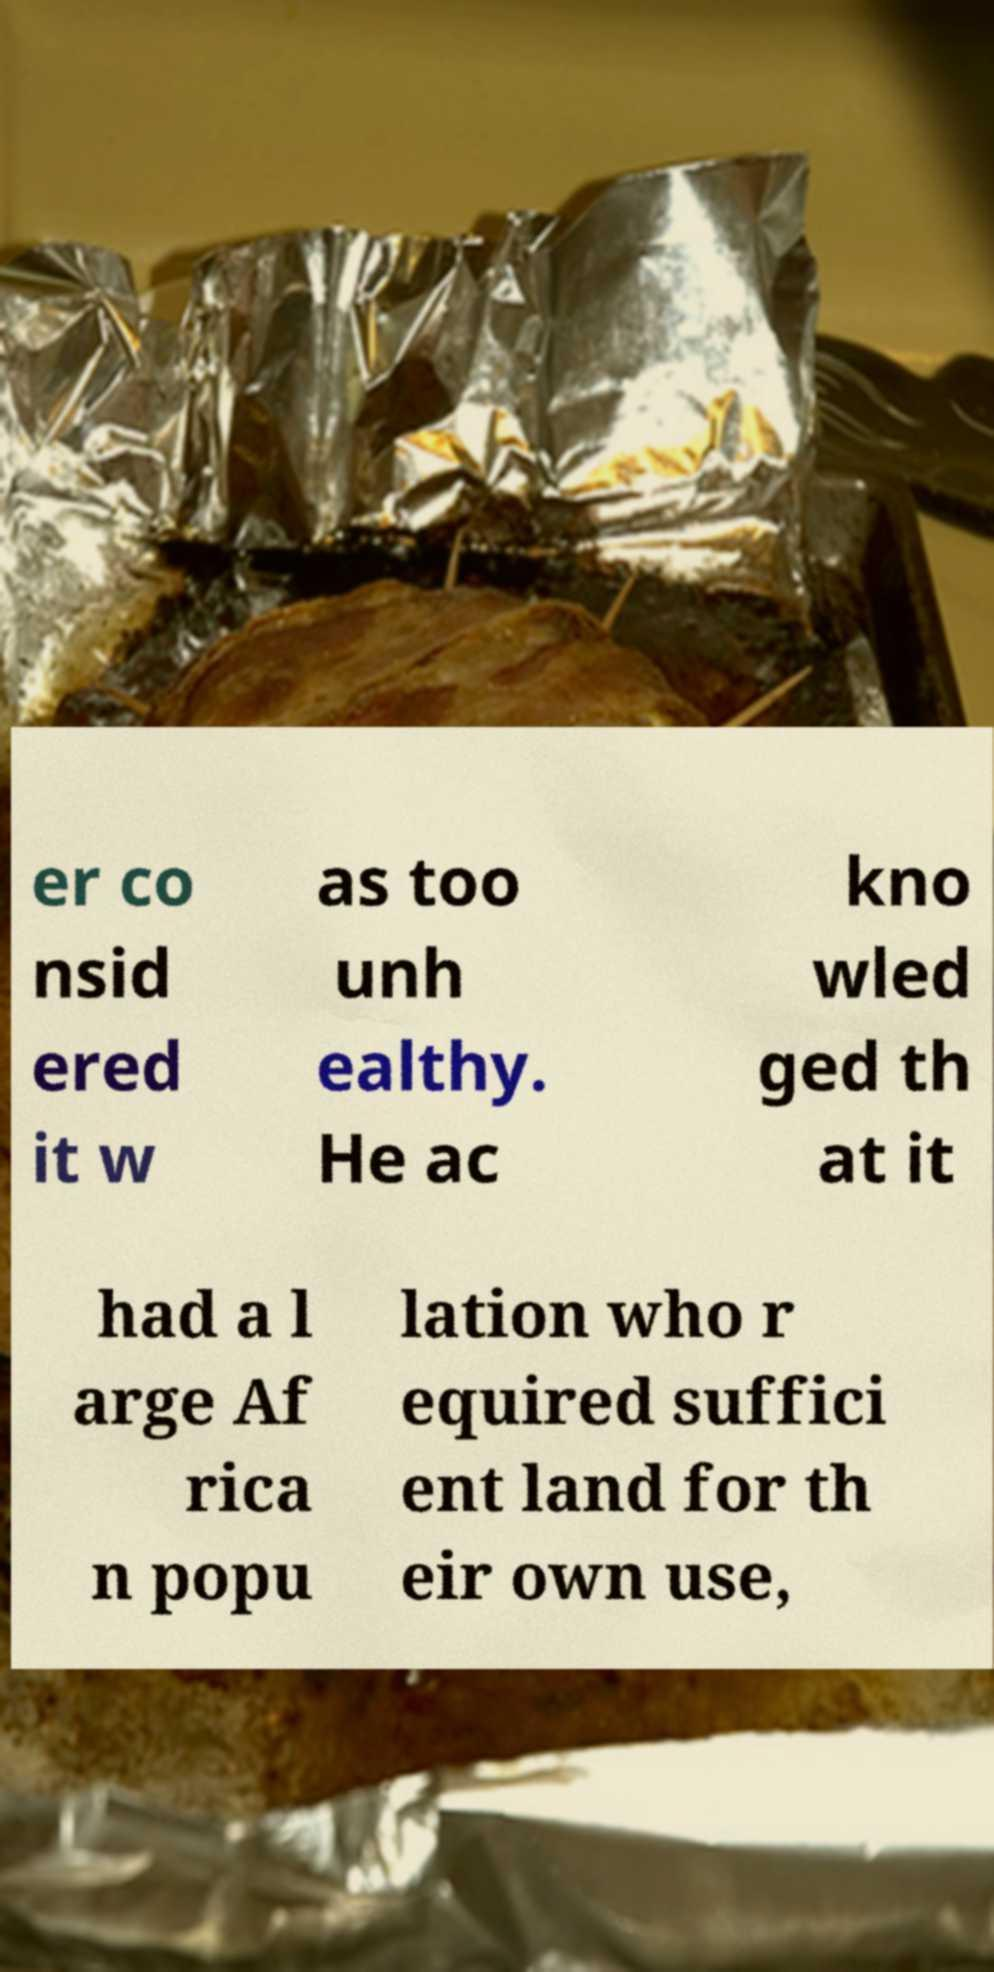Could you extract and type out the text from this image? er co nsid ered it w as too unh ealthy. He ac kno wled ged th at it had a l arge Af rica n popu lation who r equired suffici ent land for th eir own use, 